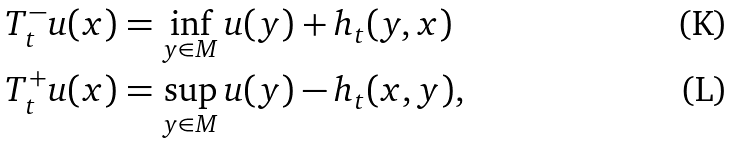<formula> <loc_0><loc_0><loc_500><loc_500>T _ { t } ^ { - } u ( x ) & = \inf _ { y \in M } u ( y ) + h _ { t } ( y , x ) \\ T _ { t } ^ { + } u ( x ) & = \sup _ { y \in M } u ( y ) - h _ { t } ( x , y ) ,</formula> 